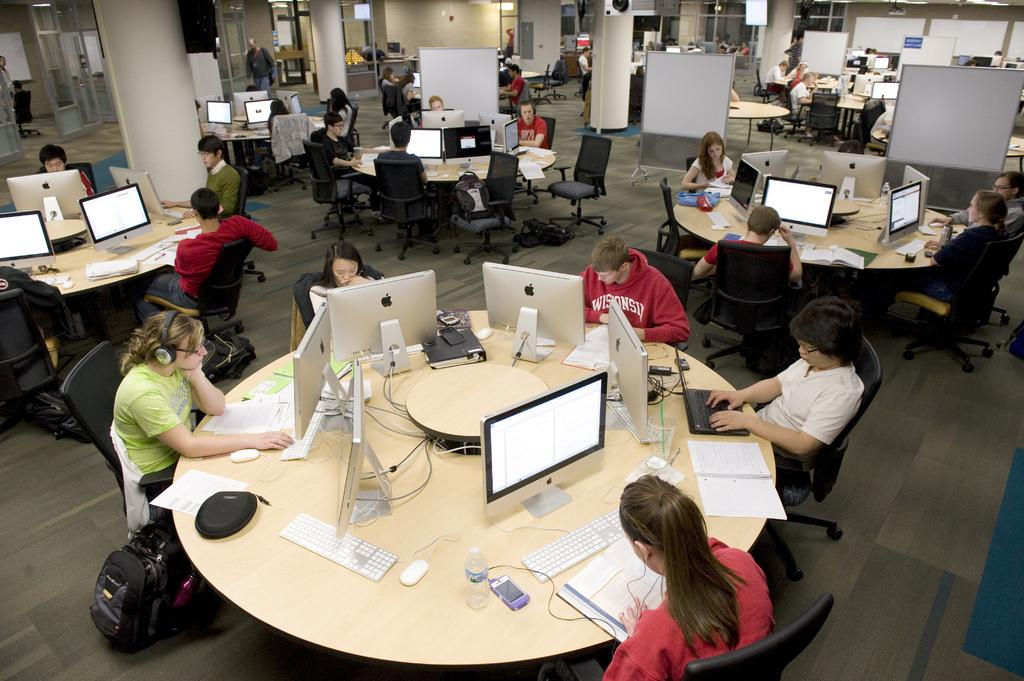Who or what can be seen in the image? There are people in the image. What are the people doing in the image? The people are sitting on chairs. What objects are present on the table in the image? There are monitors on a table in the image. What type of road can be seen in the image? There is no road present in the image; it features people sitting on chairs with monitors on a table. Can you hear the people talking in the image? The image is a still picture, so it does not capture any sound, including the people talking. 